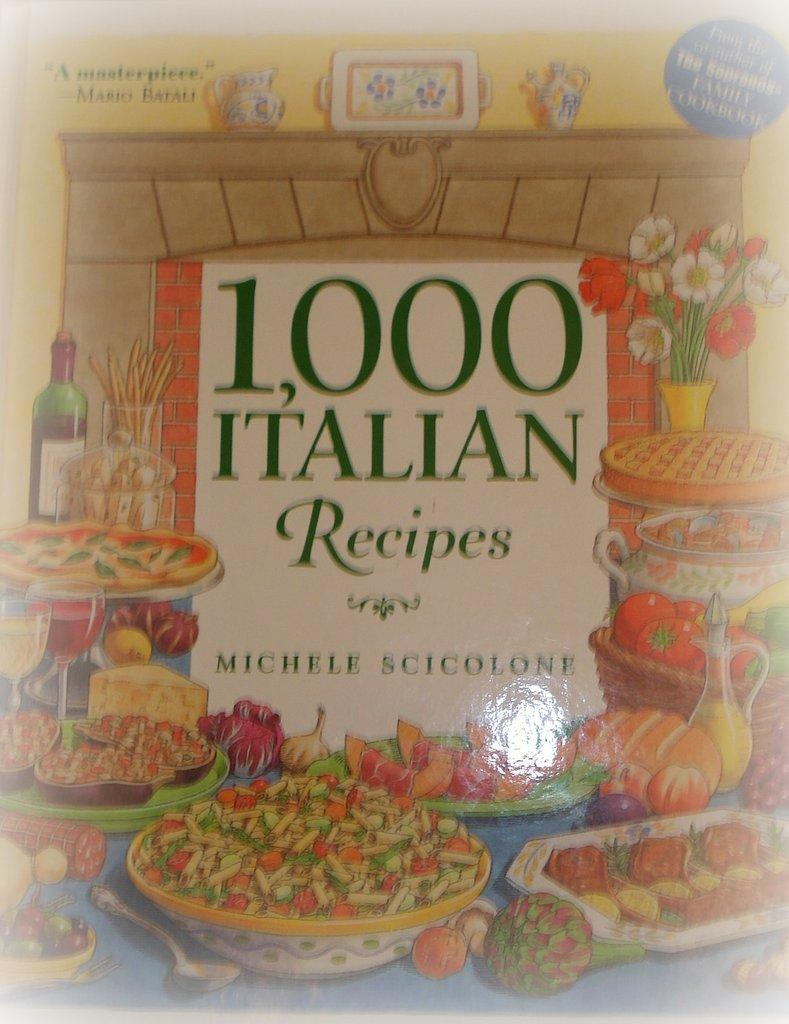<image>
Give a short and clear explanation of the subsequent image. A book with 1,000 Italian Recipes by Michelle Scicolone. 